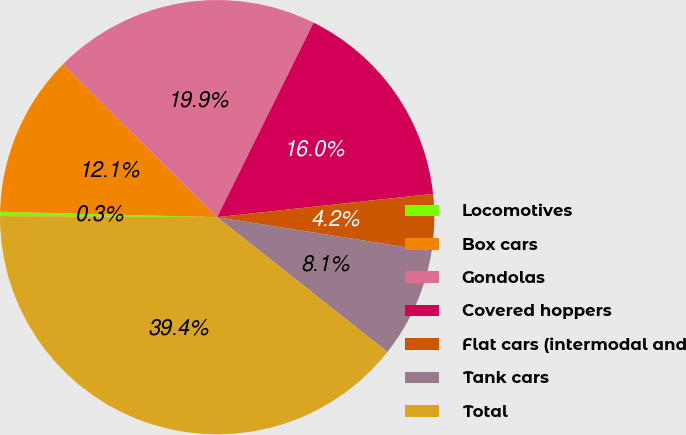<chart> <loc_0><loc_0><loc_500><loc_500><pie_chart><fcel>Locomotives<fcel>Box cars<fcel>Gondolas<fcel>Covered hoppers<fcel>Flat cars (intermodal and<fcel>Tank cars<fcel>Total<nl><fcel>0.32%<fcel>12.05%<fcel>19.87%<fcel>15.96%<fcel>4.23%<fcel>8.14%<fcel>39.42%<nl></chart> 